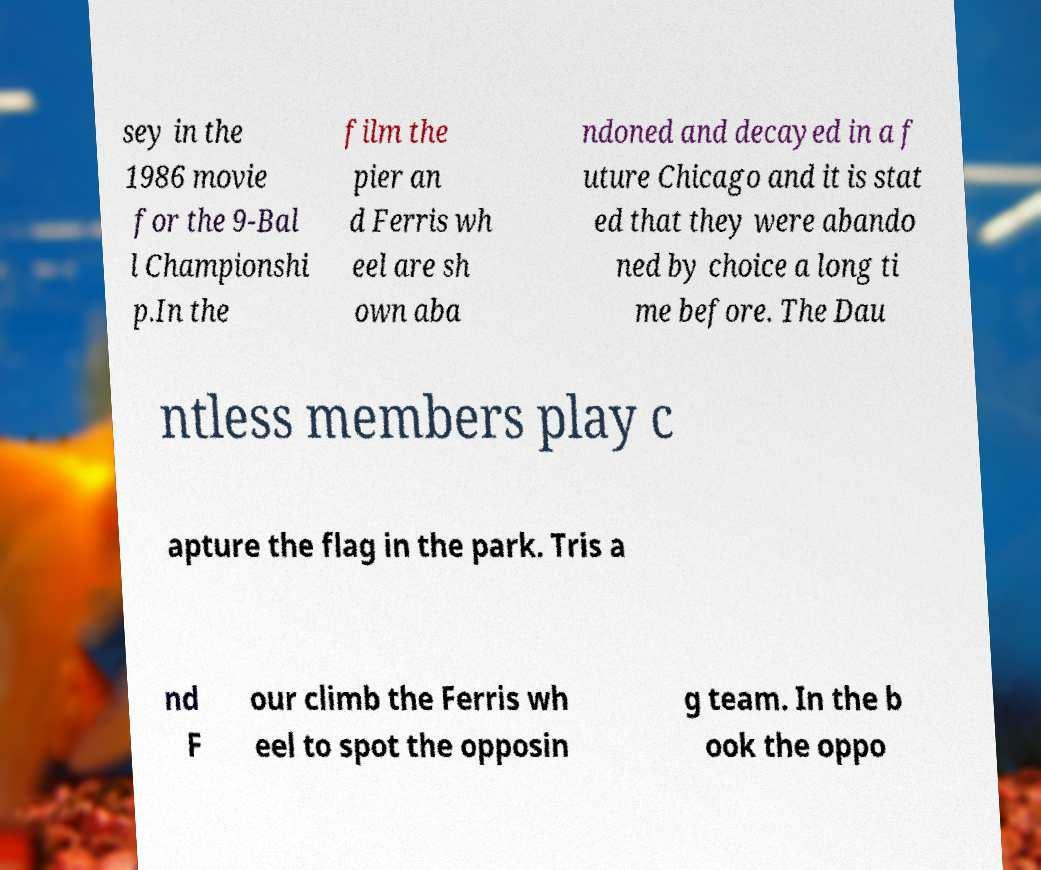What messages or text are displayed in this image? I need them in a readable, typed format. sey in the 1986 movie for the 9-Bal l Championshi p.In the film the pier an d Ferris wh eel are sh own aba ndoned and decayed in a f uture Chicago and it is stat ed that they were abando ned by choice a long ti me before. The Dau ntless members play c apture the flag in the park. Tris a nd F our climb the Ferris wh eel to spot the opposin g team. In the b ook the oppo 